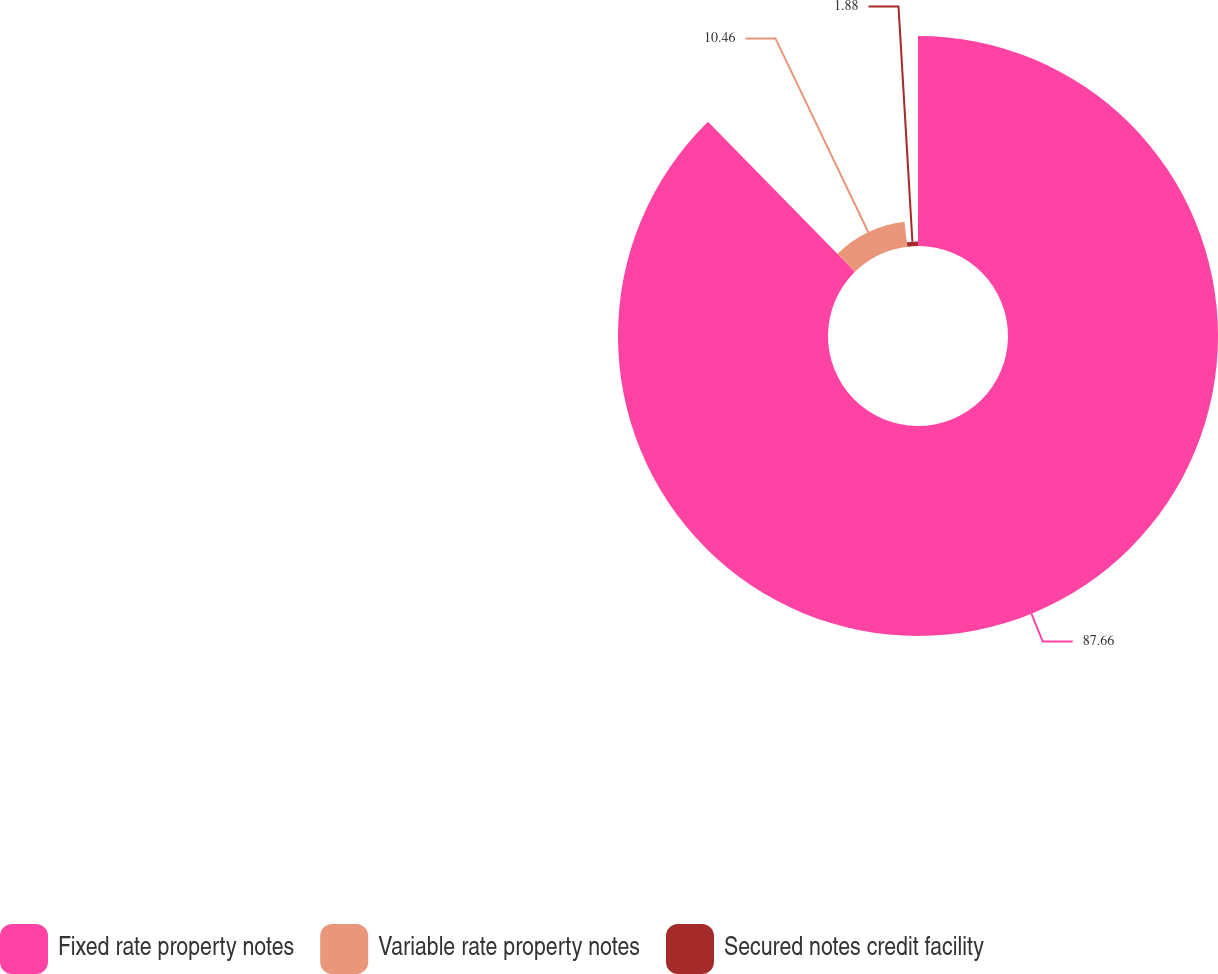Convert chart to OTSL. <chart><loc_0><loc_0><loc_500><loc_500><pie_chart><fcel>Fixed rate property notes<fcel>Variable rate property notes<fcel>Secured notes credit facility<nl><fcel>87.66%<fcel>10.46%<fcel>1.88%<nl></chart> 